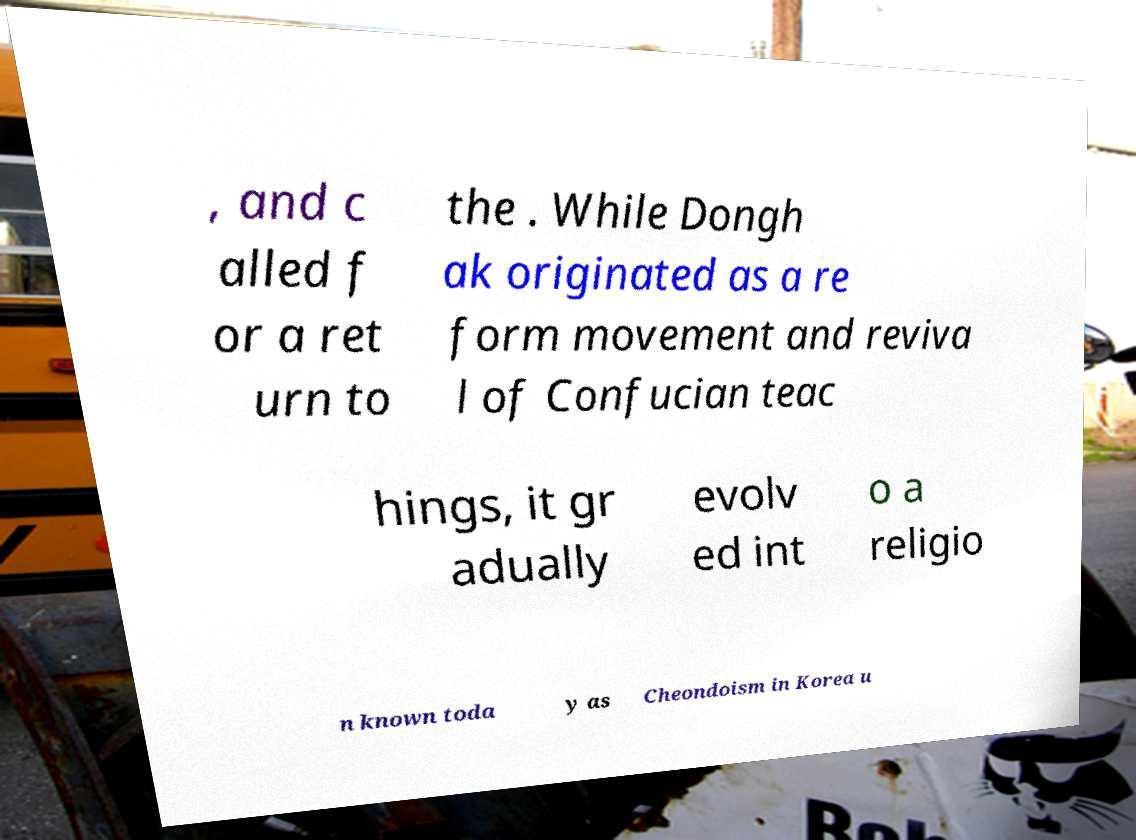Can you read and provide the text displayed in the image?This photo seems to have some interesting text. Can you extract and type it out for me? , and c alled f or a ret urn to the . While Dongh ak originated as a re form movement and reviva l of Confucian teac hings, it gr adually evolv ed int o a religio n known toda y as Cheondoism in Korea u 